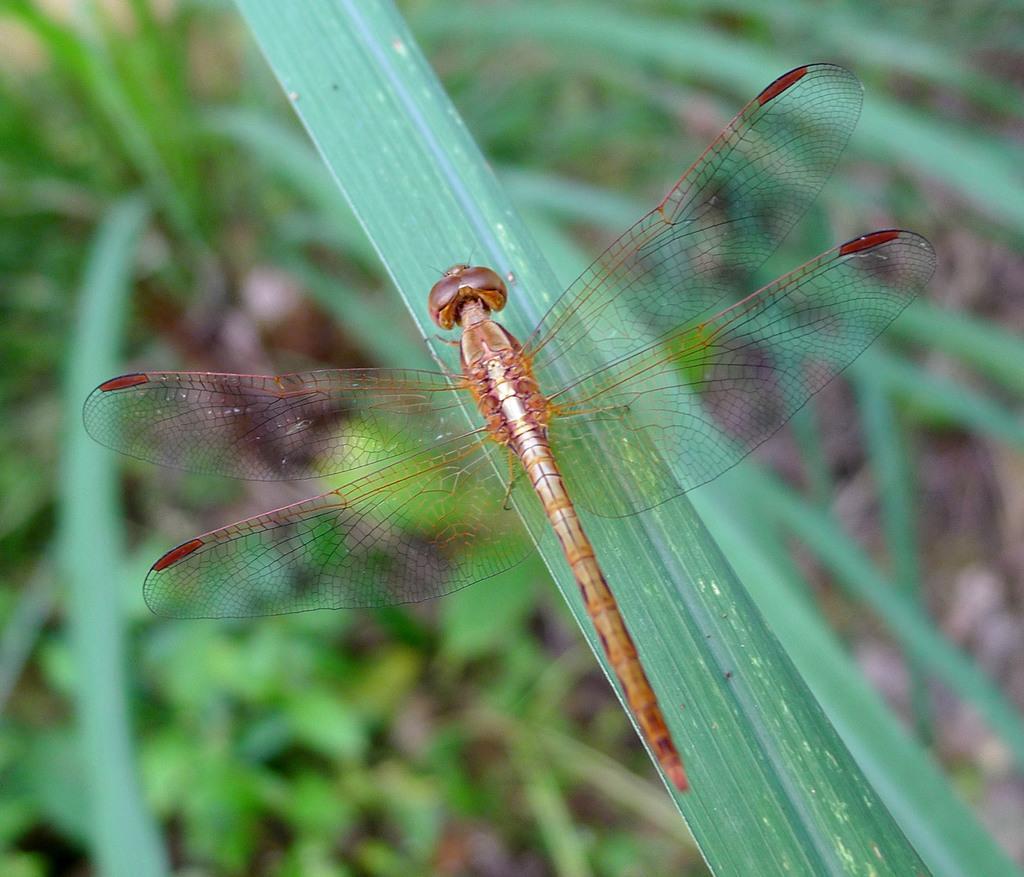How would you summarize this image in a sentence or two? Here we can see an insect on a leaf. In the background there are plants on the ground. 